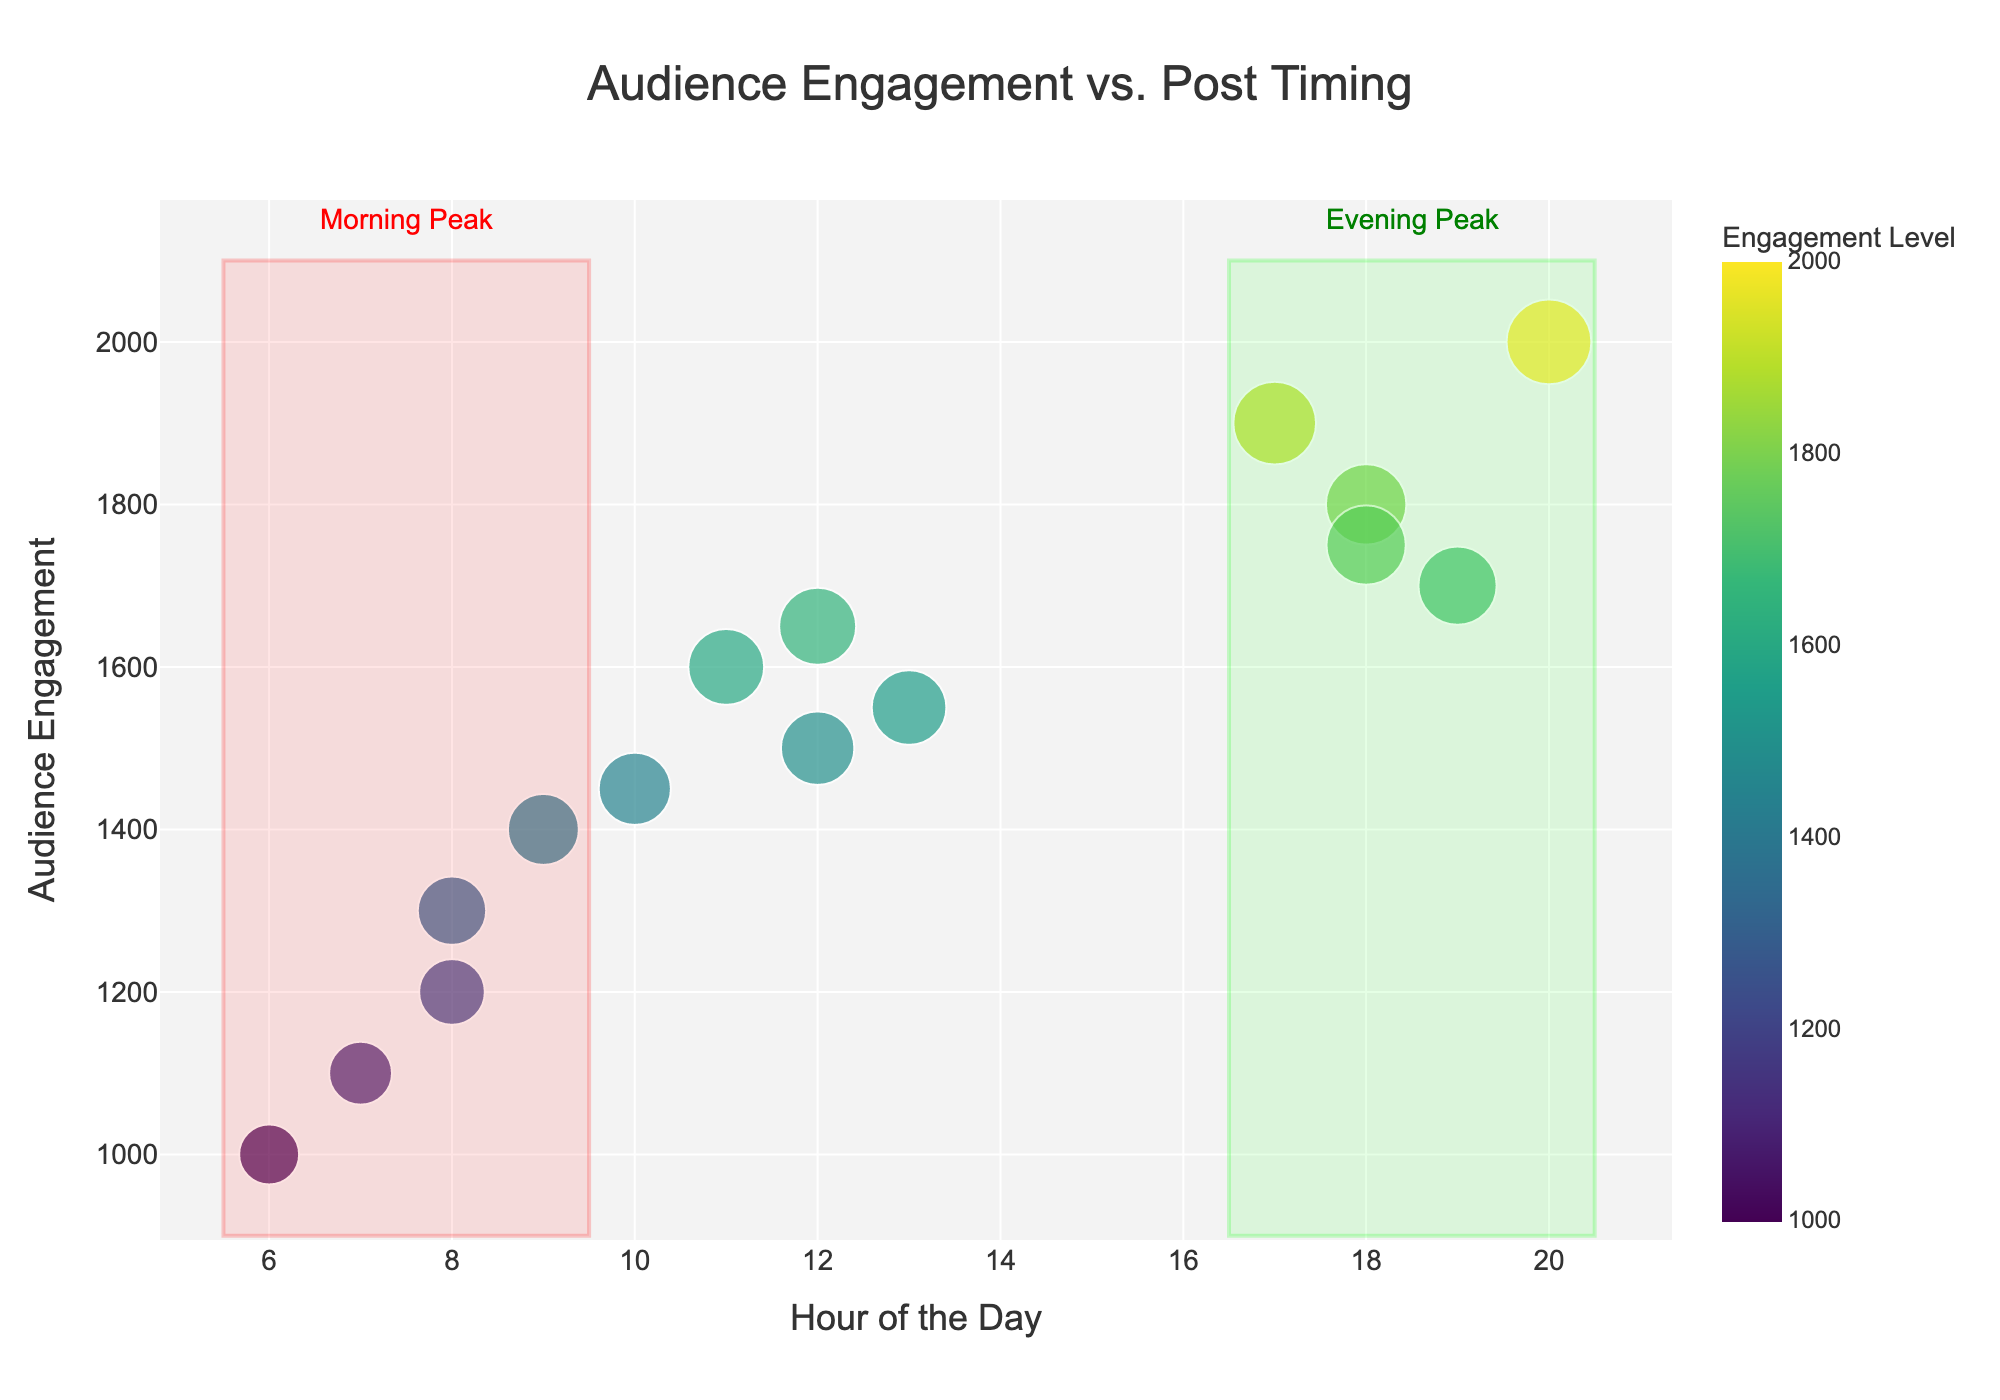What's the title of the figure? The title is usually displayed at the top of the figure and provides a summary of what is being shown. In this scatter plot, the title should be centered and in a larger font.
Answer: Audience Engagement vs. Post Timing What is the color range used in the scatter plot? The figure uses a continuous color scale to represent engagement levels. The colors transition through shades from the "Viridis" color scale.
Answer: Viridis color scale How many data points were plotted in the scatter plot? Count the number of distinct points plotted in the scatter plot. Each point represents an individual data entry.
Answer: 15 What time of day is indicated by the "Morning Peak" annotation? The "Morning Peak" annotation is surrounded by a rectangular highlighted area, showing the specific time range it covers.
Answer: 6:00 AM to 10:00 AM What time of day is indicated by the "Evening Peak" annotation? The "Evening Peak" annotation is surrounded by a rectangular highlighted area, showing the specific time range it covers.
Answer: 5:00 PM to 9:00 PM What is the highest engagement value recorded in the figure? Look for the data point that is plotted highest on the y-axis, which represents engagement. The engagement level is also indicated by the size and color intensity of the point.
Answer: 2000 How does the engagement level vary with posting time in the "Morning Peak" window? Look at the data points within the "Morning Peak" highlighted area and compare their engagement levels (size and color) to those outside this range. Morning points show a mix of lower and moderate engagement compared to other times.
Answer: Lower to moderate Between the "Morning Peak" and "Evening Peak," which has higher engagement on average? Summarize all engagement levels within each peak window and calculate the average for comparison. Generally, evening points tend to show higher engagement due to more intense colors and larger sizes.
Answer: Evening Peak Which part of the day has the most outliers in terms of engagement level, and what are their values? Identify points that lie far from the rest inside a time window, like early morning, noon, and late evening areas, especially noting any cluster around extremes.
Answer: Late evening (8:00 PM, Engagement = 2000) What's the general trend between post timing and engagement level as seen from the scatter plot? Observe the general pattern and concentration of points in terms of their size and color. Later in the day, the points become larger and darker, showing a trend of increasing engagement levels.
Answer: Engagement increases in the evening 